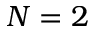<formula> <loc_0><loc_0><loc_500><loc_500>N = 2</formula> 